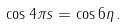<formula> <loc_0><loc_0><loc_500><loc_500>\cos 4 \pi s = \cos 6 \eta \, .</formula> 